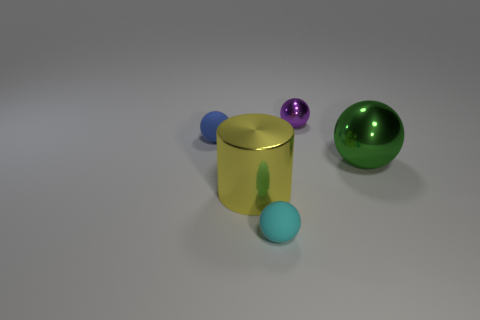Is the number of blue spheres less than the number of small red rubber things?
Your response must be concise. No. There is a rubber ball that is in front of the yellow metal object; what size is it?
Your answer should be very brief. Small. There is a object that is both behind the large green sphere and to the left of the purple ball; what shape is it?
Ensure brevity in your answer.  Sphere. There is a cyan matte thing that is the same shape as the small blue rubber object; what is its size?
Provide a succinct answer. Small. How many big green cylinders have the same material as the green sphere?
Provide a succinct answer. 0. Is the color of the large metallic cylinder the same as the big metallic thing that is right of the tiny purple ball?
Provide a short and direct response. No. Are there more purple spheres than matte things?
Your answer should be compact. No. What color is the small metallic ball?
Offer a terse response. Purple. Does the matte ball that is behind the large sphere have the same color as the tiny metal sphere?
Offer a very short reply. No. What number of big shiny objects are the same color as the small metal ball?
Keep it short and to the point. 0. 